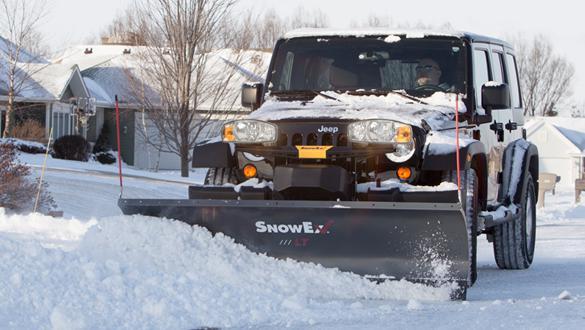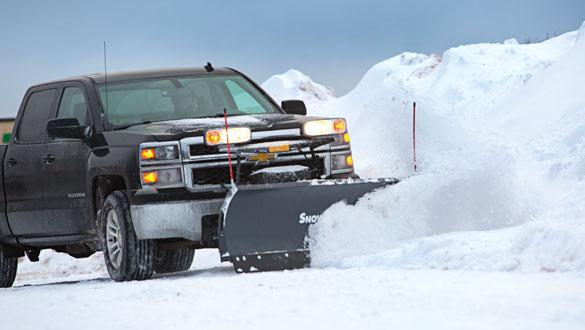The first image is the image on the left, the second image is the image on the right. Evaluate the accuracy of this statement regarding the images: "All images include a vehicle pushing a bright yellow plow through snow, and one image features a truck with a bright yellow cab.". Is it true? Answer yes or no. No. The first image is the image on the left, the second image is the image on the right. For the images shown, is this caption "A pickup truck with a yellow bulldozer front attachment is pushing a pile of snow." true? Answer yes or no. No. 